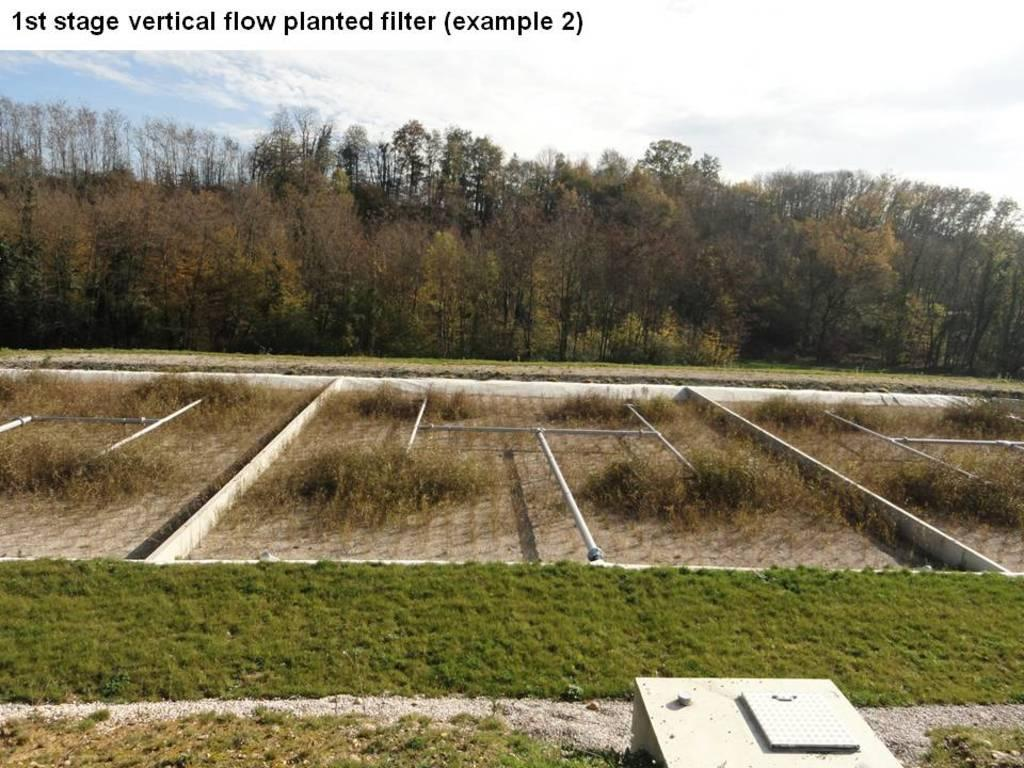What type of landscape is shown in the image? There is a forming land in the image. What type of vegetation is present on the land? Grass is present on the land. What can be seen at the top of the image? There are trees and the sky visible at the top of the image. How many baskets are hanging from the trees in the image? There are no baskets visible in the image; only trees and the sky are present at the top of the image. 